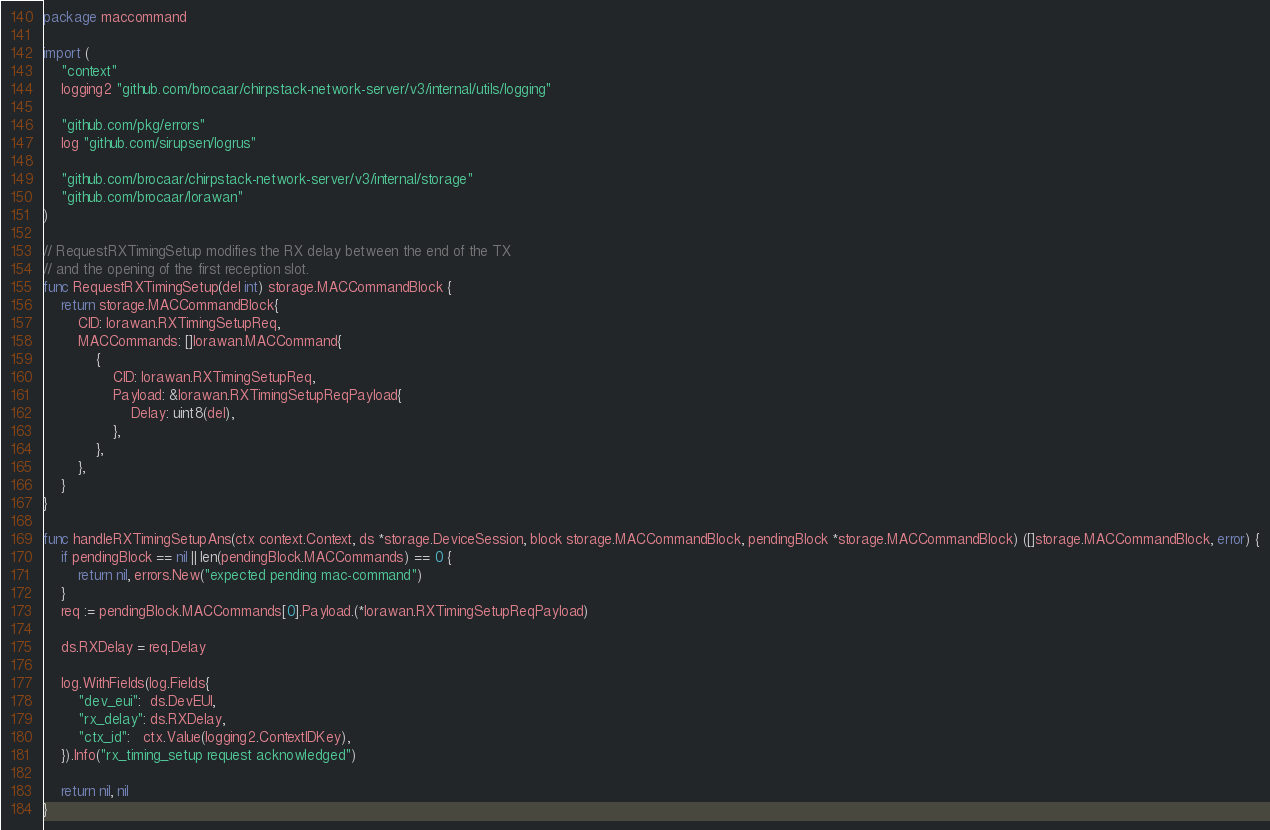Convert code to text. <code><loc_0><loc_0><loc_500><loc_500><_Go_>package maccommand

import (
	"context"
	logging2 "github.com/brocaar/chirpstack-network-server/v3/internal/utils/logging"

	"github.com/pkg/errors"
	log "github.com/sirupsen/logrus"

	"github.com/brocaar/chirpstack-network-server/v3/internal/storage"
	"github.com/brocaar/lorawan"
)

// RequestRXTimingSetup modifies the RX delay between the end of the TX
// and the opening of the first reception slot.
func RequestRXTimingSetup(del int) storage.MACCommandBlock {
	return storage.MACCommandBlock{
		CID: lorawan.RXTimingSetupReq,
		MACCommands: []lorawan.MACCommand{
			{
				CID: lorawan.RXTimingSetupReq,
				Payload: &lorawan.RXTimingSetupReqPayload{
					Delay: uint8(del),
				},
			},
		},
	}
}

func handleRXTimingSetupAns(ctx context.Context, ds *storage.DeviceSession, block storage.MACCommandBlock, pendingBlock *storage.MACCommandBlock) ([]storage.MACCommandBlock, error) {
	if pendingBlock == nil || len(pendingBlock.MACCommands) == 0 {
		return nil, errors.New("expected pending mac-command")
	}
	req := pendingBlock.MACCommands[0].Payload.(*lorawan.RXTimingSetupReqPayload)

	ds.RXDelay = req.Delay

	log.WithFields(log.Fields{
		"dev_eui":  ds.DevEUI,
		"rx_delay": ds.RXDelay,
		"ctx_id":   ctx.Value(logging2.ContextIDKey),
	}).Info("rx_timing_setup request acknowledged")

	return nil, nil
}
</code> 